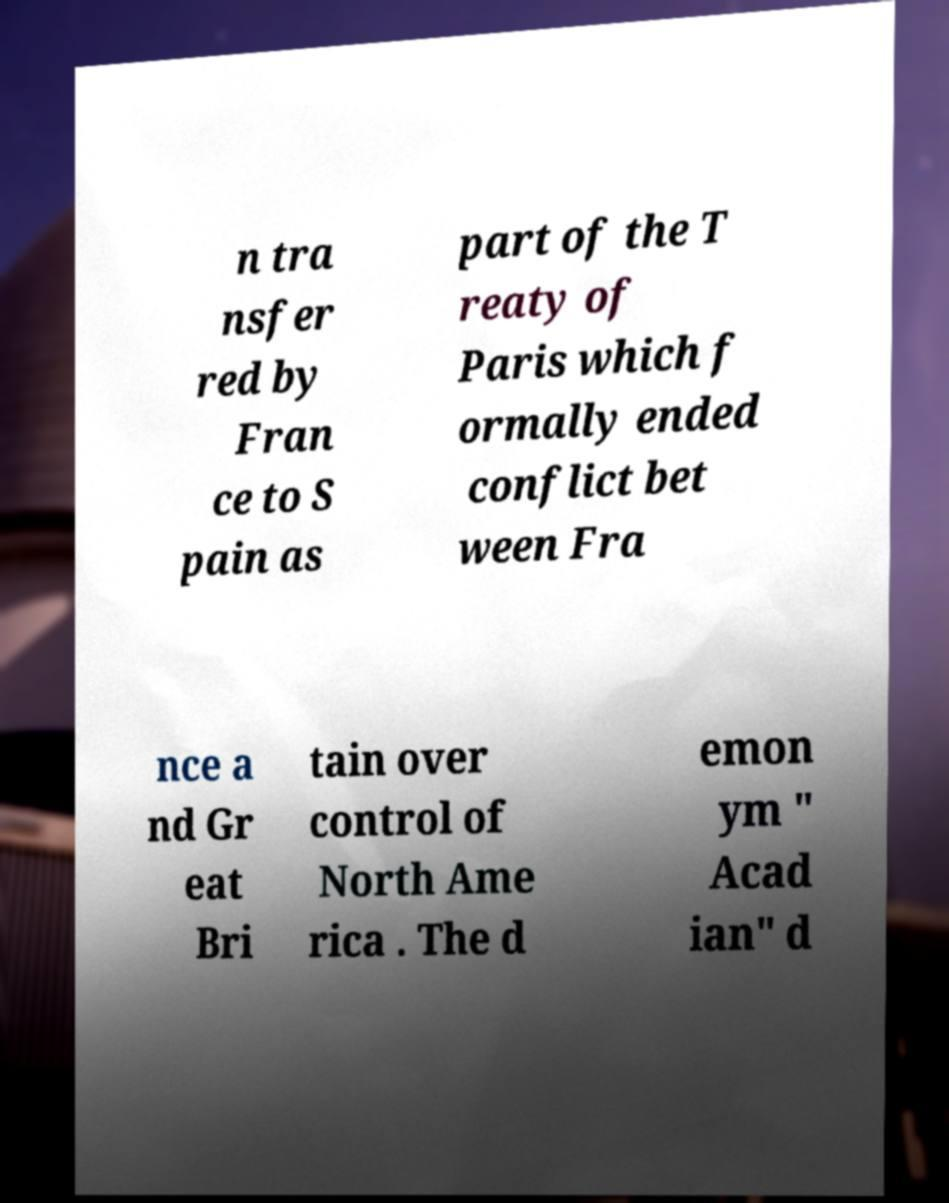Please read and relay the text visible in this image. What does it say? n tra nsfer red by Fran ce to S pain as part of the T reaty of Paris which f ormally ended conflict bet ween Fra nce a nd Gr eat Bri tain over control of North Ame rica . The d emon ym " Acad ian" d 